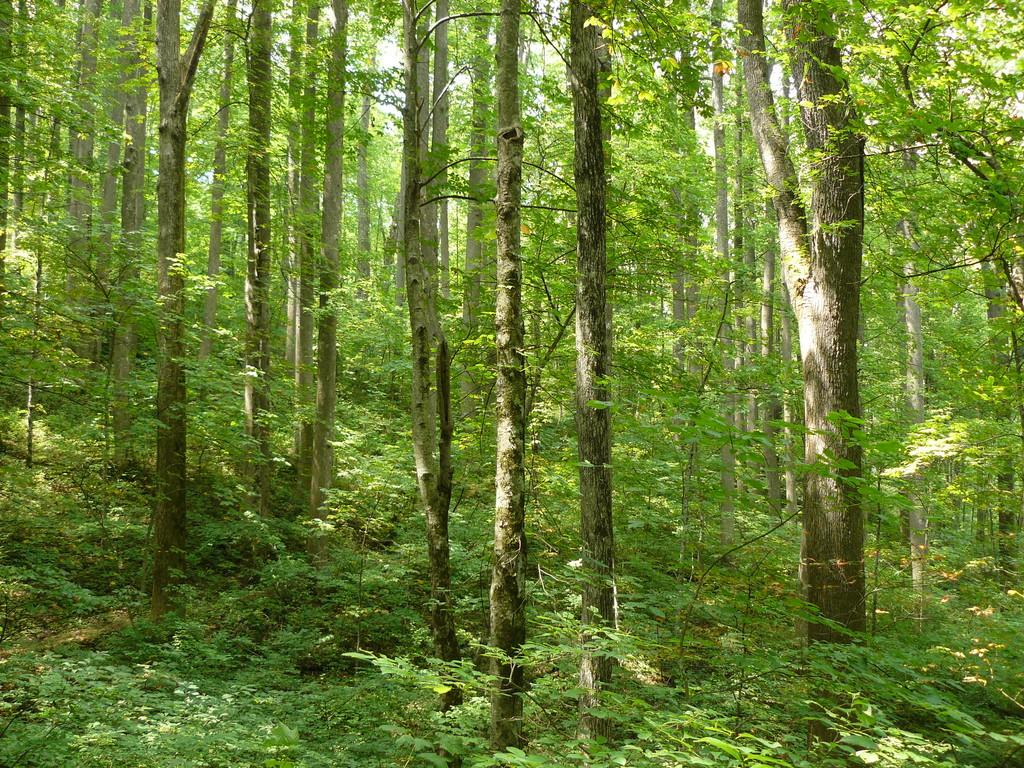What type of vegetation can be seen in the image? There are trees and plants in the image. What part of the natural environment is visible in the image? The sky is visible in the image. Can you describe the vegetation in the image? The trees and plants in the image are likely part of a natural landscape or garden. Who is the owner of the glove in the image? There is no glove present in the image, so it is not possible to determine the owner. 